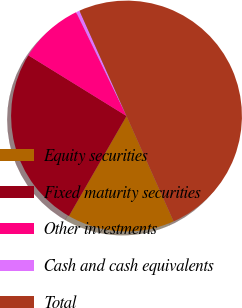<chart> <loc_0><loc_0><loc_500><loc_500><pie_chart><fcel>Equity securities<fcel>Fixed maturity securities<fcel>Other investments<fcel>Cash and cash equivalents<fcel>Total<nl><fcel>15.0%<fcel>25.5%<fcel>9.0%<fcel>0.5%<fcel>50.0%<nl></chart> 